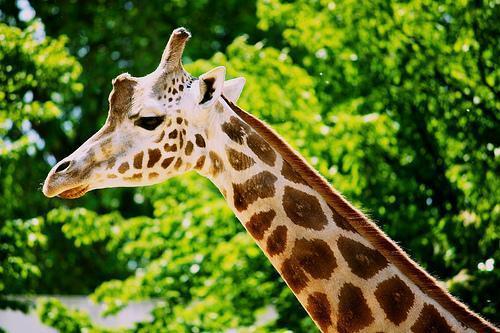How many giraffes are visible in this photo?
Give a very brief answer. 1. How many ears are visible?
Give a very brief answer. 2. 